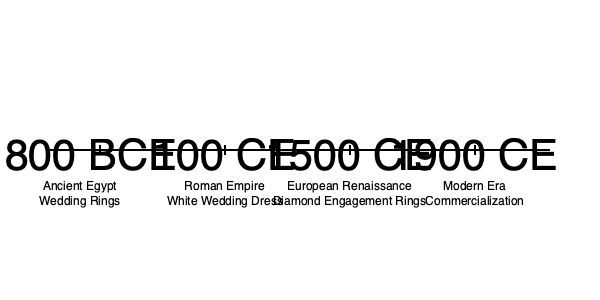Based on the timeline, which wedding tradition emerged earliest and how might this tradition have reinforced societal norms of the time? To answer this question, we need to analyze the timeline chronologically:

1. The earliest tradition shown is from 1800 BCE in Ancient Egypt: Wedding Rings.
2. The next tradition is from 100 CE in the Roman Empire: White Wedding Dress.
3. Following that, we see Diamond Engagement Rings from 1500 CE during the European Renaissance.
4. The most recent entry is from 1900 CE, indicating the Commercialization of weddings in the Modern Era.

The earliest tradition is clearly the use of wedding rings in Ancient Egypt (1800 BCE).

Regarding how this tradition might have reinforced societal norms:

1. Symbolism of ownership: Rings could have symbolized a man's ownership of his wife, reinforcing patriarchal norms.
2. Social status: The material of the ring might have indicated wealth and social standing, reinforcing class distinctions.
3. Commitment and fidelity: Rings symbolized an eternal bond, potentially reinforcing monogamy and lifetime commitments.
4. Religious significance: Rings might have had spiritual meanings, reinforcing the connection between marriage and religious beliefs.

This tradition, while seemingly innocuous, could have played a role in cementing various social, economic, and gender-based norms in ancient Egyptian society.
Answer: Wedding rings (1800 BCE), potentially reinforcing ownership, status, commitment, and religious norms. 